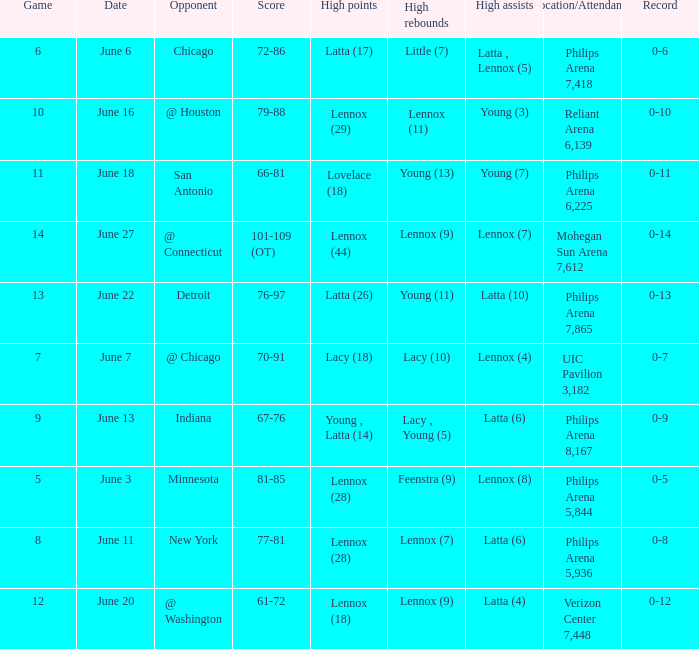What stadium hosted the June 7 game and how many visitors were there? UIC Pavilion 3,182. 